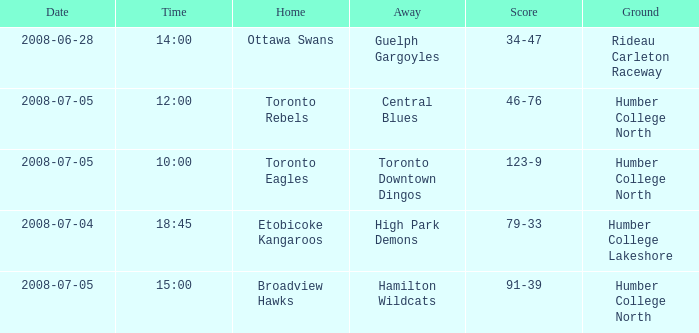What is the Date with a Time that is 18:45? 2008-07-04. 